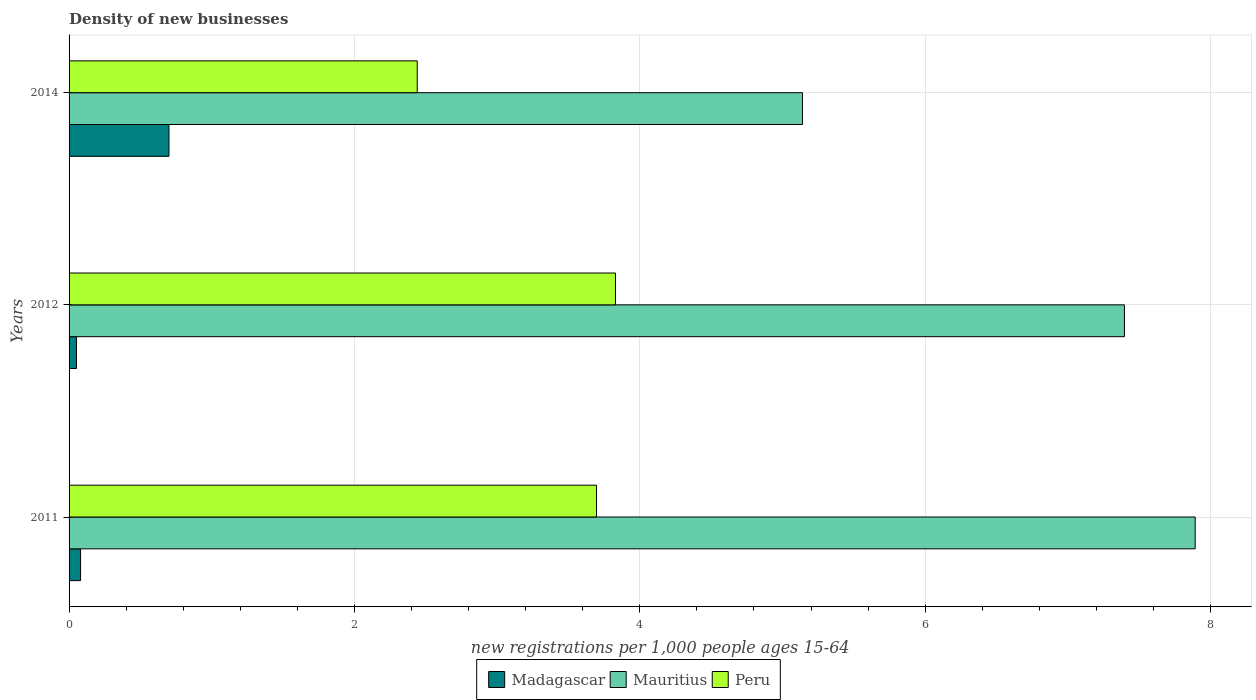How many different coloured bars are there?
Provide a short and direct response. 3. How many groups of bars are there?
Make the answer very short. 3. Are the number of bars per tick equal to the number of legend labels?
Your answer should be compact. Yes. How many bars are there on the 3rd tick from the top?
Give a very brief answer. 3. What is the number of new registrations in Peru in 2012?
Give a very brief answer. 3.83. Across all years, what is the maximum number of new registrations in Mauritius?
Ensure brevity in your answer.  7.89. Across all years, what is the minimum number of new registrations in Peru?
Make the answer very short. 2.44. In which year was the number of new registrations in Peru maximum?
Keep it short and to the point. 2012. What is the total number of new registrations in Mauritius in the graph?
Ensure brevity in your answer.  20.43. What is the difference between the number of new registrations in Mauritius in 2011 and that in 2012?
Your response must be concise. 0.5. What is the difference between the number of new registrations in Madagascar in 2014 and the number of new registrations in Mauritius in 2012?
Your answer should be compact. -6.7. What is the average number of new registrations in Mauritius per year?
Your response must be concise. 6.81. In the year 2014, what is the difference between the number of new registrations in Madagascar and number of new registrations in Peru?
Give a very brief answer. -1.74. What is the ratio of the number of new registrations in Madagascar in 2011 to that in 2014?
Ensure brevity in your answer.  0.11. Is the difference between the number of new registrations in Madagascar in 2011 and 2012 greater than the difference between the number of new registrations in Peru in 2011 and 2012?
Your answer should be very brief. Yes. What is the difference between the highest and the second highest number of new registrations in Madagascar?
Your response must be concise. 0.62. What is the difference between the highest and the lowest number of new registrations in Mauritius?
Offer a terse response. 2.75. Is the sum of the number of new registrations in Madagascar in 2011 and 2014 greater than the maximum number of new registrations in Peru across all years?
Ensure brevity in your answer.  No. What does the 3rd bar from the top in 2014 represents?
Give a very brief answer. Madagascar. What does the 1st bar from the bottom in 2014 represents?
Your answer should be very brief. Madagascar. How many bars are there?
Offer a terse response. 9. How many years are there in the graph?
Your response must be concise. 3. What is the difference between two consecutive major ticks on the X-axis?
Your response must be concise. 2. Are the values on the major ticks of X-axis written in scientific E-notation?
Your answer should be compact. No. Does the graph contain any zero values?
Your answer should be compact. No. Does the graph contain grids?
Make the answer very short. Yes. How many legend labels are there?
Your response must be concise. 3. How are the legend labels stacked?
Provide a succinct answer. Horizontal. What is the title of the graph?
Make the answer very short. Density of new businesses. What is the label or title of the X-axis?
Provide a succinct answer. New registrations per 1,0 people ages 15-64. What is the label or title of the Y-axis?
Provide a short and direct response. Years. What is the new registrations per 1,000 people ages 15-64 of Madagascar in 2011?
Offer a terse response. 0.08. What is the new registrations per 1,000 people ages 15-64 of Mauritius in 2011?
Offer a very short reply. 7.89. What is the new registrations per 1,000 people ages 15-64 in Peru in 2011?
Your response must be concise. 3.7. What is the new registrations per 1,000 people ages 15-64 of Madagascar in 2012?
Offer a terse response. 0.05. What is the new registrations per 1,000 people ages 15-64 in Mauritius in 2012?
Your answer should be compact. 7.4. What is the new registrations per 1,000 people ages 15-64 in Peru in 2012?
Provide a short and direct response. 3.83. What is the new registrations per 1,000 people ages 15-64 in Mauritius in 2014?
Make the answer very short. 5.14. What is the new registrations per 1,000 people ages 15-64 of Peru in 2014?
Your answer should be compact. 2.44. Across all years, what is the maximum new registrations per 1,000 people ages 15-64 in Madagascar?
Your answer should be very brief. 0.7. Across all years, what is the maximum new registrations per 1,000 people ages 15-64 of Mauritius?
Offer a terse response. 7.89. Across all years, what is the maximum new registrations per 1,000 people ages 15-64 in Peru?
Provide a succinct answer. 3.83. Across all years, what is the minimum new registrations per 1,000 people ages 15-64 in Madagascar?
Provide a succinct answer. 0.05. Across all years, what is the minimum new registrations per 1,000 people ages 15-64 in Mauritius?
Provide a succinct answer. 5.14. Across all years, what is the minimum new registrations per 1,000 people ages 15-64 in Peru?
Give a very brief answer. 2.44. What is the total new registrations per 1,000 people ages 15-64 of Madagascar in the graph?
Keep it short and to the point. 0.83. What is the total new registrations per 1,000 people ages 15-64 of Mauritius in the graph?
Offer a terse response. 20.43. What is the total new registrations per 1,000 people ages 15-64 in Peru in the graph?
Offer a terse response. 9.97. What is the difference between the new registrations per 1,000 people ages 15-64 of Madagascar in 2011 and that in 2012?
Provide a succinct answer. 0.03. What is the difference between the new registrations per 1,000 people ages 15-64 in Mauritius in 2011 and that in 2012?
Your answer should be compact. 0.5. What is the difference between the new registrations per 1,000 people ages 15-64 in Peru in 2011 and that in 2012?
Offer a very short reply. -0.13. What is the difference between the new registrations per 1,000 people ages 15-64 of Madagascar in 2011 and that in 2014?
Offer a terse response. -0.62. What is the difference between the new registrations per 1,000 people ages 15-64 in Mauritius in 2011 and that in 2014?
Offer a terse response. 2.75. What is the difference between the new registrations per 1,000 people ages 15-64 of Peru in 2011 and that in 2014?
Give a very brief answer. 1.26. What is the difference between the new registrations per 1,000 people ages 15-64 of Madagascar in 2012 and that in 2014?
Provide a succinct answer. -0.65. What is the difference between the new registrations per 1,000 people ages 15-64 of Mauritius in 2012 and that in 2014?
Make the answer very short. 2.26. What is the difference between the new registrations per 1,000 people ages 15-64 of Peru in 2012 and that in 2014?
Your answer should be compact. 1.39. What is the difference between the new registrations per 1,000 people ages 15-64 in Madagascar in 2011 and the new registrations per 1,000 people ages 15-64 in Mauritius in 2012?
Your answer should be very brief. -7.32. What is the difference between the new registrations per 1,000 people ages 15-64 of Madagascar in 2011 and the new registrations per 1,000 people ages 15-64 of Peru in 2012?
Ensure brevity in your answer.  -3.75. What is the difference between the new registrations per 1,000 people ages 15-64 of Mauritius in 2011 and the new registrations per 1,000 people ages 15-64 of Peru in 2012?
Your answer should be compact. 4.06. What is the difference between the new registrations per 1,000 people ages 15-64 of Madagascar in 2011 and the new registrations per 1,000 people ages 15-64 of Mauritius in 2014?
Provide a short and direct response. -5.06. What is the difference between the new registrations per 1,000 people ages 15-64 of Madagascar in 2011 and the new registrations per 1,000 people ages 15-64 of Peru in 2014?
Offer a very short reply. -2.36. What is the difference between the new registrations per 1,000 people ages 15-64 in Mauritius in 2011 and the new registrations per 1,000 people ages 15-64 in Peru in 2014?
Offer a very short reply. 5.45. What is the difference between the new registrations per 1,000 people ages 15-64 in Madagascar in 2012 and the new registrations per 1,000 people ages 15-64 in Mauritius in 2014?
Ensure brevity in your answer.  -5.09. What is the difference between the new registrations per 1,000 people ages 15-64 in Madagascar in 2012 and the new registrations per 1,000 people ages 15-64 in Peru in 2014?
Provide a succinct answer. -2.39. What is the difference between the new registrations per 1,000 people ages 15-64 of Mauritius in 2012 and the new registrations per 1,000 people ages 15-64 of Peru in 2014?
Offer a very short reply. 4.96. What is the average new registrations per 1,000 people ages 15-64 in Madagascar per year?
Provide a short and direct response. 0.28. What is the average new registrations per 1,000 people ages 15-64 of Mauritius per year?
Provide a succinct answer. 6.81. What is the average new registrations per 1,000 people ages 15-64 in Peru per year?
Your response must be concise. 3.32. In the year 2011, what is the difference between the new registrations per 1,000 people ages 15-64 of Madagascar and new registrations per 1,000 people ages 15-64 of Mauritius?
Provide a succinct answer. -7.81. In the year 2011, what is the difference between the new registrations per 1,000 people ages 15-64 of Madagascar and new registrations per 1,000 people ages 15-64 of Peru?
Ensure brevity in your answer.  -3.62. In the year 2011, what is the difference between the new registrations per 1,000 people ages 15-64 of Mauritius and new registrations per 1,000 people ages 15-64 of Peru?
Give a very brief answer. 4.2. In the year 2012, what is the difference between the new registrations per 1,000 people ages 15-64 in Madagascar and new registrations per 1,000 people ages 15-64 in Mauritius?
Offer a very short reply. -7.34. In the year 2012, what is the difference between the new registrations per 1,000 people ages 15-64 in Madagascar and new registrations per 1,000 people ages 15-64 in Peru?
Your answer should be compact. -3.78. In the year 2012, what is the difference between the new registrations per 1,000 people ages 15-64 in Mauritius and new registrations per 1,000 people ages 15-64 in Peru?
Give a very brief answer. 3.57. In the year 2014, what is the difference between the new registrations per 1,000 people ages 15-64 in Madagascar and new registrations per 1,000 people ages 15-64 in Mauritius?
Offer a terse response. -4.44. In the year 2014, what is the difference between the new registrations per 1,000 people ages 15-64 of Madagascar and new registrations per 1,000 people ages 15-64 of Peru?
Give a very brief answer. -1.74. What is the ratio of the new registrations per 1,000 people ages 15-64 in Madagascar in 2011 to that in 2012?
Ensure brevity in your answer.  1.55. What is the ratio of the new registrations per 1,000 people ages 15-64 in Mauritius in 2011 to that in 2012?
Your response must be concise. 1.07. What is the ratio of the new registrations per 1,000 people ages 15-64 in Peru in 2011 to that in 2012?
Your response must be concise. 0.97. What is the ratio of the new registrations per 1,000 people ages 15-64 in Madagascar in 2011 to that in 2014?
Provide a short and direct response. 0.12. What is the ratio of the new registrations per 1,000 people ages 15-64 of Mauritius in 2011 to that in 2014?
Your answer should be very brief. 1.54. What is the ratio of the new registrations per 1,000 people ages 15-64 of Peru in 2011 to that in 2014?
Make the answer very short. 1.51. What is the ratio of the new registrations per 1,000 people ages 15-64 in Madagascar in 2012 to that in 2014?
Offer a terse response. 0.07. What is the ratio of the new registrations per 1,000 people ages 15-64 of Mauritius in 2012 to that in 2014?
Provide a succinct answer. 1.44. What is the ratio of the new registrations per 1,000 people ages 15-64 of Peru in 2012 to that in 2014?
Your response must be concise. 1.57. What is the difference between the highest and the second highest new registrations per 1,000 people ages 15-64 of Madagascar?
Your response must be concise. 0.62. What is the difference between the highest and the second highest new registrations per 1,000 people ages 15-64 in Mauritius?
Provide a succinct answer. 0.5. What is the difference between the highest and the second highest new registrations per 1,000 people ages 15-64 of Peru?
Offer a very short reply. 0.13. What is the difference between the highest and the lowest new registrations per 1,000 people ages 15-64 in Madagascar?
Offer a very short reply. 0.65. What is the difference between the highest and the lowest new registrations per 1,000 people ages 15-64 of Mauritius?
Give a very brief answer. 2.75. What is the difference between the highest and the lowest new registrations per 1,000 people ages 15-64 in Peru?
Your response must be concise. 1.39. 